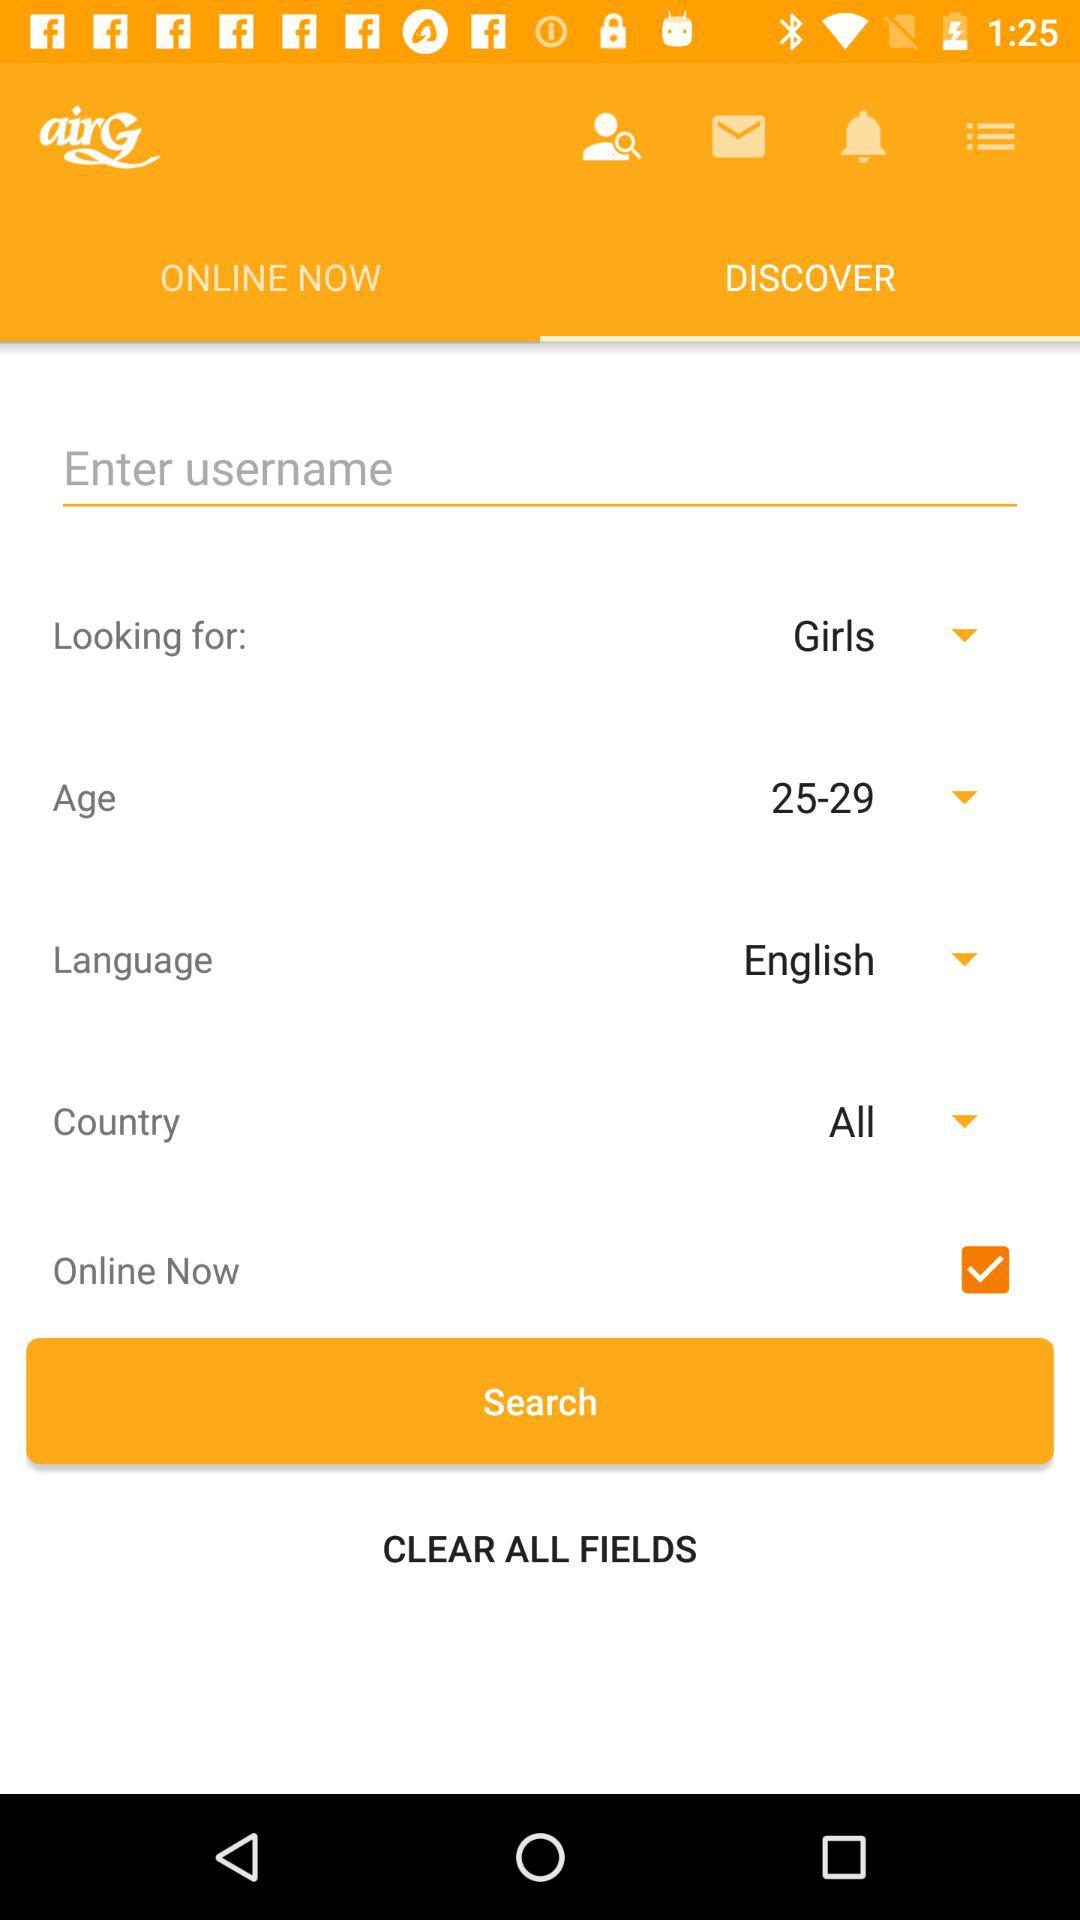Which option is selected in looking for? The selected option in Looking for is "Girls". 